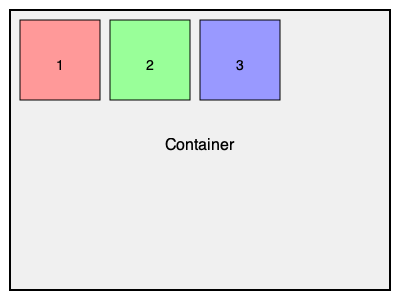Given a CSS flexbox container with three flex items as shown in the image, which CSS property should be applied to the container to align the items horizontally with equal space between and around them? To align flex items horizontally with equal space between and around them, we need to use the `justify-content` property on the flex container. Here's a step-by-step explanation:

1. The `justify-content` property is used to align flex items along the main axis of the flex container.

2. In this case, the main axis is horizontal (assuming the default `flex-direction: row`).

3. To create equal space between and around the items, we use the value `space-evenly`.

4. The `space-evenly` value distributes the remaining space evenly between all items, including before the first item and after the last item.

5. The CSS rule for the container would be:
   ```css
   .container {
     display: flex;
     justify-content: space-evenly;
   }
   ```

This property will ensure that the three flex items are evenly spaced horizontally within the container, as shown in the image.
Answer: justify-content: space-evenly; 